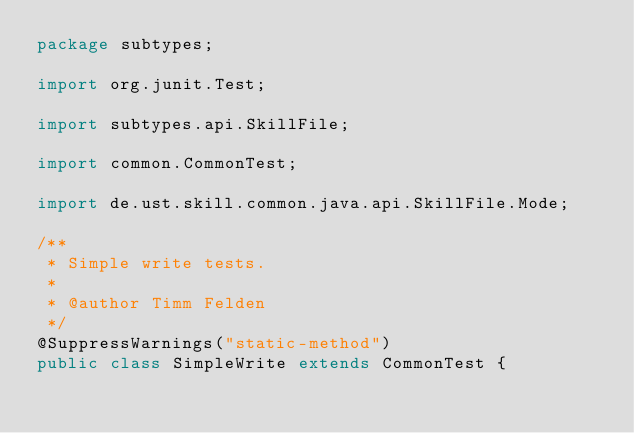<code> <loc_0><loc_0><loc_500><loc_500><_Java_>package subtypes;

import org.junit.Test;

import subtypes.api.SkillFile;

import common.CommonTest;

import de.ust.skill.common.java.api.SkillFile.Mode;

/**
 * Simple write tests.
 * 
 * @author Timm Felden
 */
@SuppressWarnings("static-method")
public class SimpleWrite extends CommonTest {
</code> 